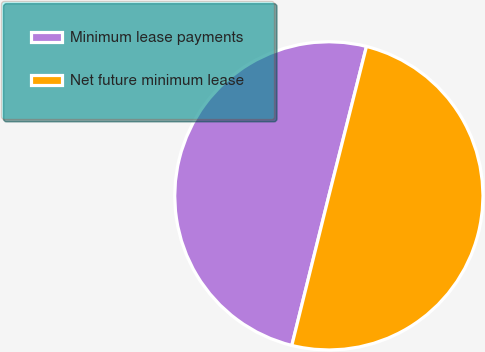Convert chart to OTSL. <chart><loc_0><loc_0><loc_500><loc_500><pie_chart><fcel>Minimum lease payments<fcel>Net future minimum lease<nl><fcel>50.06%<fcel>49.94%<nl></chart> 